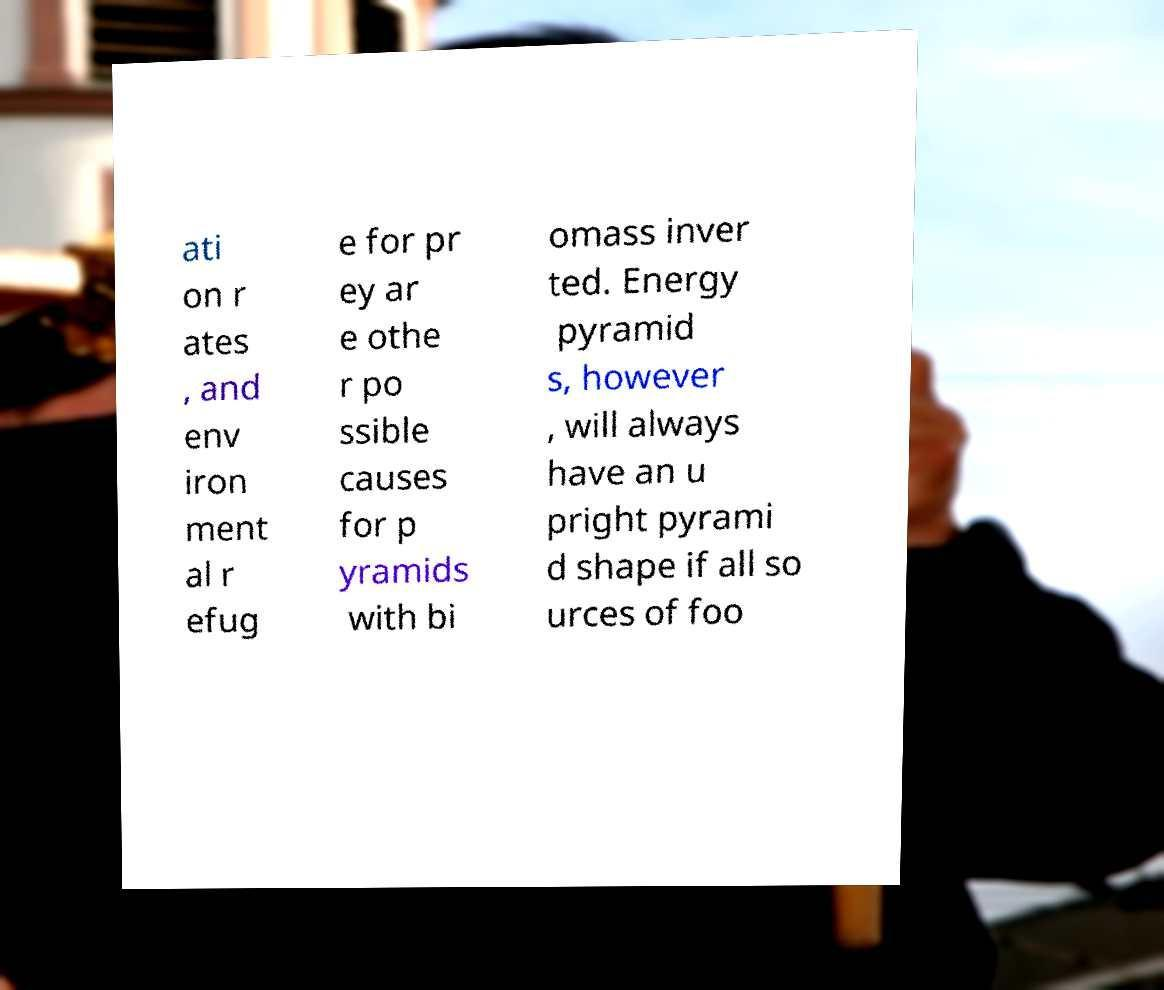Please read and relay the text visible in this image. What does it say? ati on r ates , and env iron ment al r efug e for pr ey ar e othe r po ssible causes for p yramids with bi omass inver ted. Energy pyramid s, however , will always have an u pright pyrami d shape if all so urces of foo 